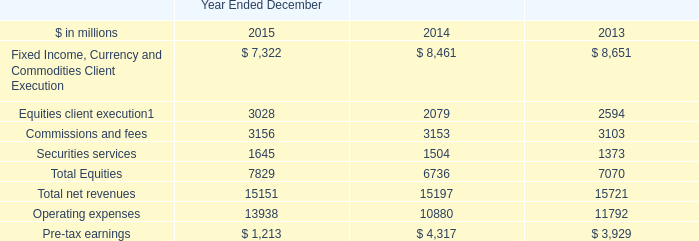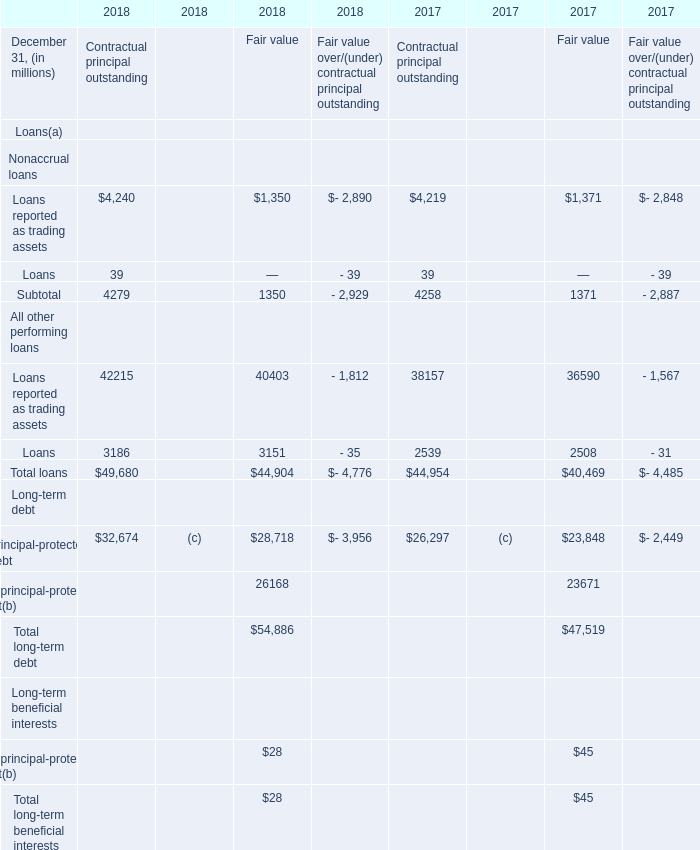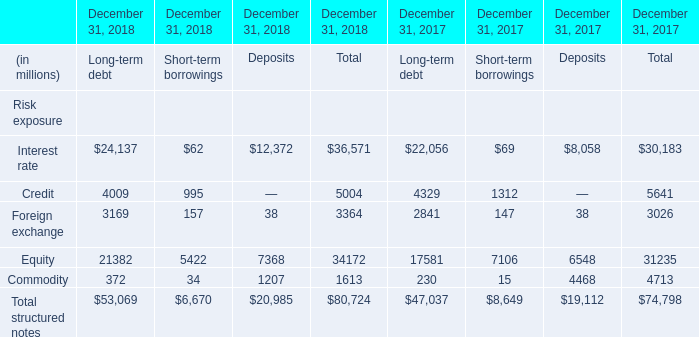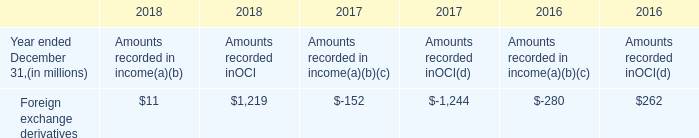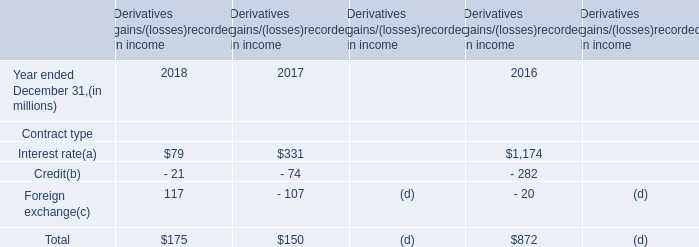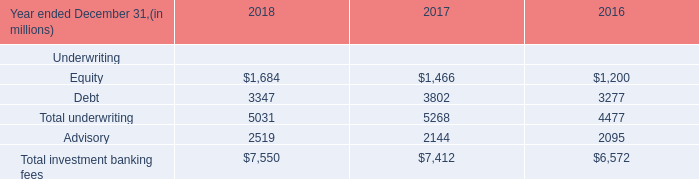What was the total amount of elements for Long-term debt in 2018? (in million) 
Computations: ((((24137 + 4009) + 3169) + 21382) + 372)
Answer: 53069.0. 